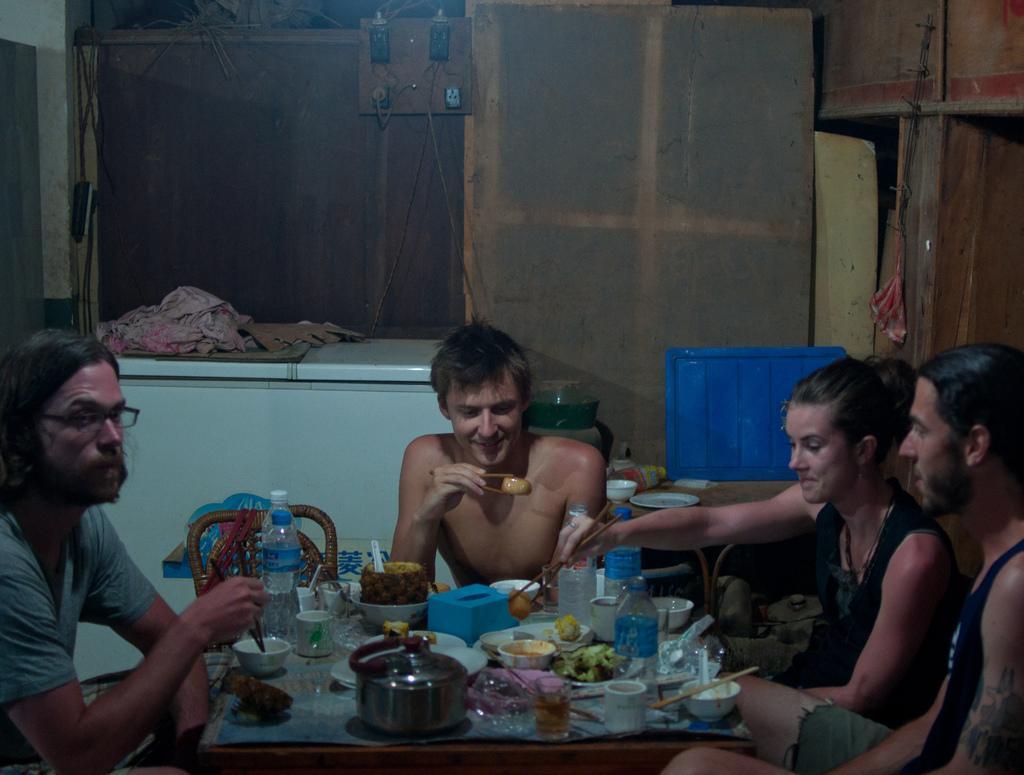How would you summarize this image in a sentence or two? In this image we can see group of persons holding chopsticks in their hands are sitting on chairs. In the foreground we can see a table containing group of cups, plates, bottles, fruit. In the background, we can see plate and bowl on a surface, cupboards,a box and a container with cloth is placed on the ground. 